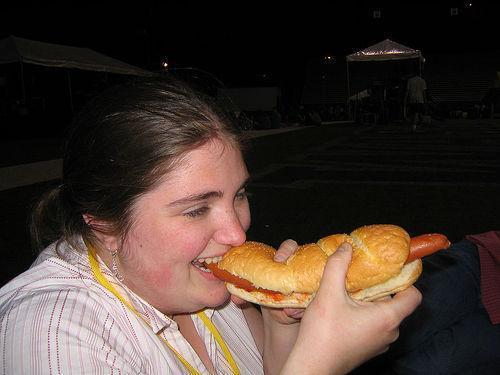How many hot dogs are there?
Give a very brief answer. 1. 